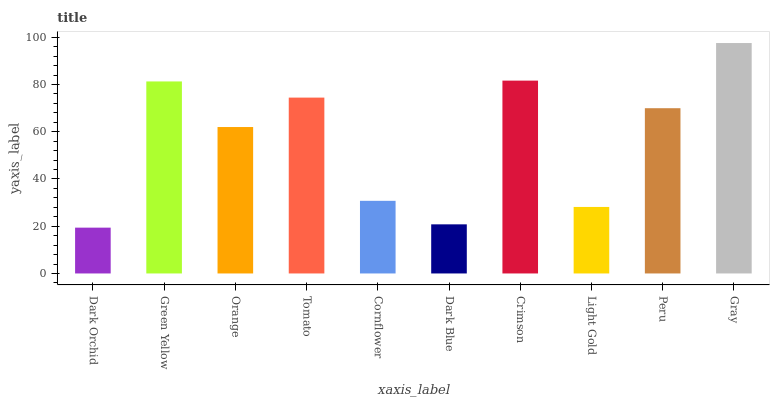Is Dark Orchid the minimum?
Answer yes or no. Yes. Is Gray the maximum?
Answer yes or no. Yes. Is Green Yellow the minimum?
Answer yes or no. No. Is Green Yellow the maximum?
Answer yes or no. No. Is Green Yellow greater than Dark Orchid?
Answer yes or no. Yes. Is Dark Orchid less than Green Yellow?
Answer yes or no. Yes. Is Dark Orchid greater than Green Yellow?
Answer yes or no. No. Is Green Yellow less than Dark Orchid?
Answer yes or no. No. Is Peru the high median?
Answer yes or no. Yes. Is Orange the low median?
Answer yes or no. Yes. Is Green Yellow the high median?
Answer yes or no. No. Is Peru the low median?
Answer yes or no. No. 